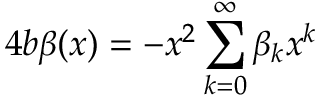Convert formula to latex. <formula><loc_0><loc_0><loc_500><loc_500>4 b \beta ( x ) = - x ^ { 2 } \sum _ { k = 0 } ^ { \infty } \beta _ { k } x ^ { k }</formula> 